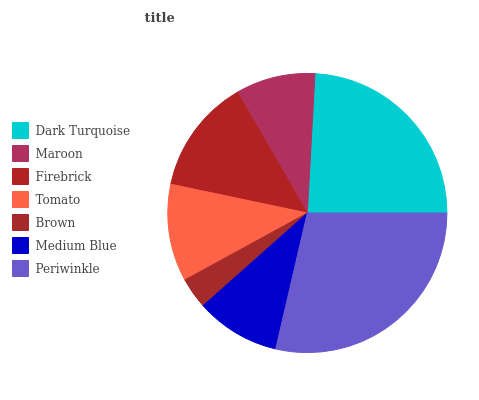Is Brown the minimum?
Answer yes or no. Yes. Is Periwinkle the maximum?
Answer yes or no. Yes. Is Maroon the minimum?
Answer yes or no. No. Is Maroon the maximum?
Answer yes or no. No. Is Dark Turquoise greater than Maroon?
Answer yes or no. Yes. Is Maroon less than Dark Turquoise?
Answer yes or no. Yes. Is Maroon greater than Dark Turquoise?
Answer yes or no. No. Is Dark Turquoise less than Maroon?
Answer yes or no. No. Is Tomato the high median?
Answer yes or no. Yes. Is Tomato the low median?
Answer yes or no. Yes. Is Firebrick the high median?
Answer yes or no. No. Is Firebrick the low median?
Answer yes or no. No. 